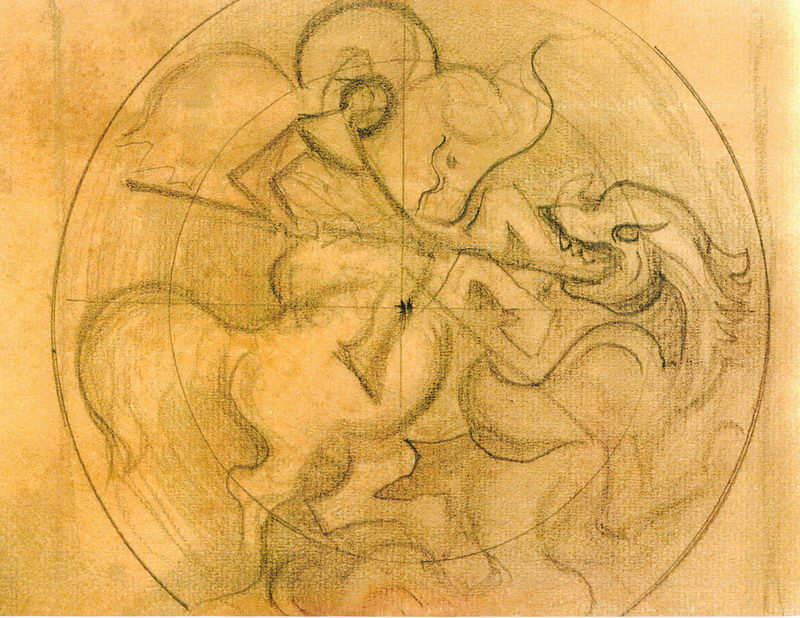Write a detailed description of the given image. The image features a tightly composed battle scene drawn within a circular frame. Several figures are illustrated in an intense skirmish, evidently from a historical or mythological context, given the classical rendition of the human forms and dynamic poses. Their muscles and expressions are vividly detailed, suggesting movement and emotion. The sketch, possibly a study for a larger work, uses a limited palette of warm earth tones that highlight the drama and fluid motion of the figures. This style is reminiscent of Renaissance artwork, where such vigorous motion and detailed anatomical rendering were commonly explored themes. 